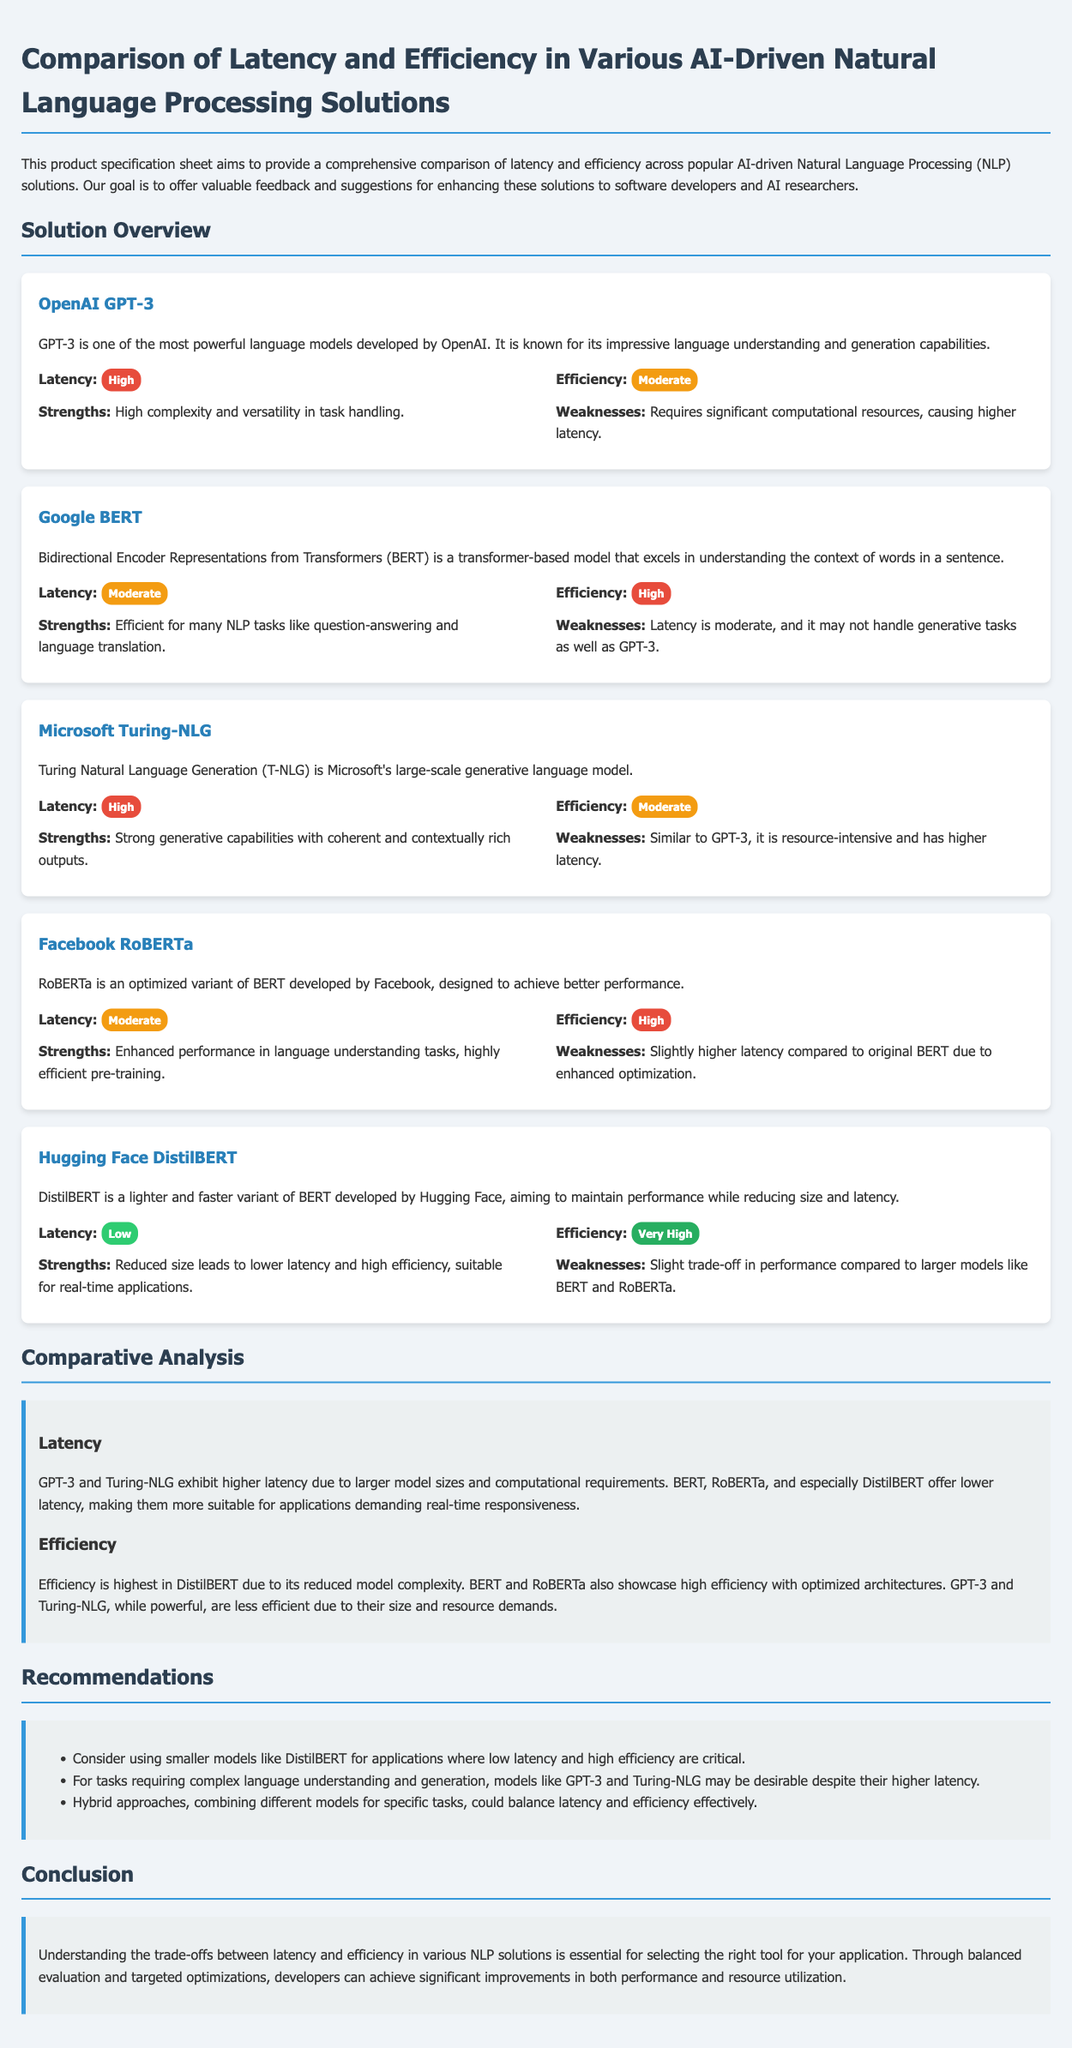What is the latency for OpenAI GPT-3? The latency for OpenAI GPT-3 is categorized as high, as stated in the document.
Answer: High What is the efficiency rating of Hugging Face DistilBERT? The efficiency rating for Hugging Face DistilBERT is labeled as very high in the document.
Answer: Very High Which model has the lowest latency? The model with the lowest latency according to the document is Hugging Face DistilBERT.
Answer: Hugging Face DistilBERT What are the strengths of Microsoft Turing-NLG? The strengths of Microsoft Turing-NLG include strong generative capabilities with coherent and contextually rich outputs.
Answer: Strong generative capabilities with coherent and contextually rich outputs Which model is recommended for applications requiring low latency? The document recommends DistilBERT for applications requiring low latency.
Answer: DistilBERT What is the weakness of Google BERT? The weakness of Google BERT is moderate latency and its performance in generative tasks compared to GPT-3.
Answer: Moderate latency and generative tasks performance Which two models exhibit higher latency? The models that exhibit higher latency as mentioned in the document are GPT-3 and Turing-NLG.
Answer: GPT-3 and Turing-NLG What is the conclusion regarding latency and efficiency trade-offs? The conclusion states that understanding trade-offs between latency and efficiency is essential for selecting the right tool.
Answer: Essential for selecting the right tool 